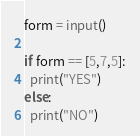Convert code to text. <code><loc_0><loc_0><loc_500><loc_500><_Python_>form = input()

if form == [5,7,5]:
  print("YES")
else:
  print("NO")
</code> 